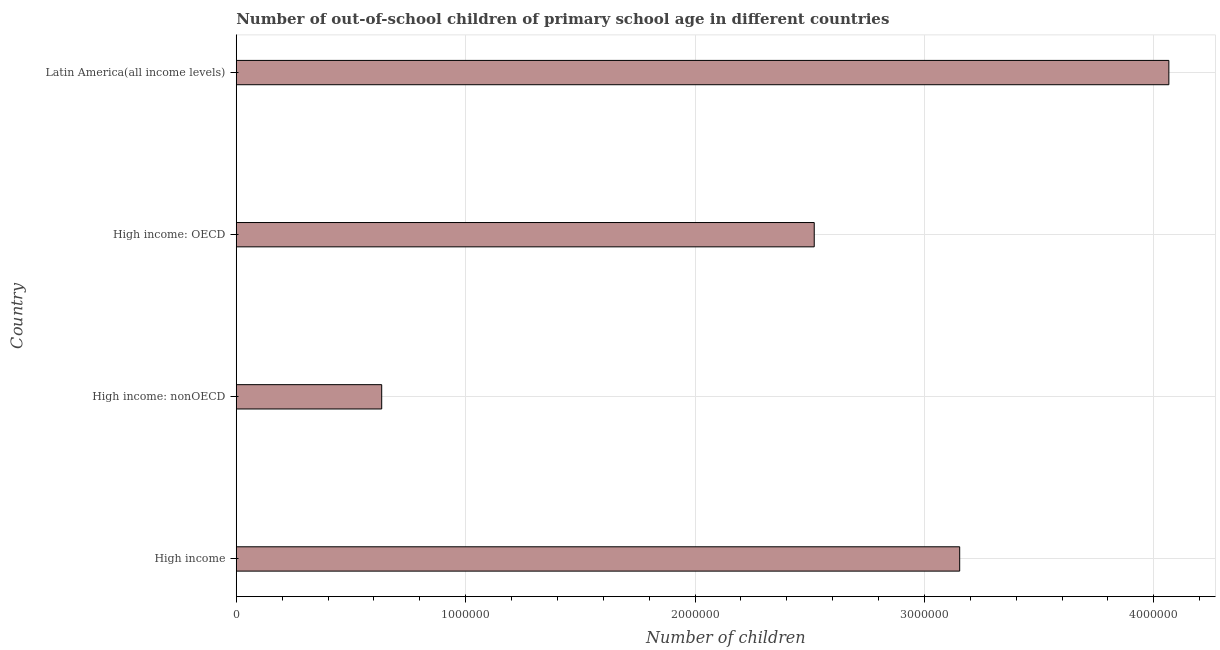Does the graph contain any zero values?
Ensure brevity in your answer.  No. Does the graph contain grids?
Your response must be concise. Yes. What is the title of the graph?
Provide a short and direct response. Number of out-of-school children of primary school age in different countries. What is the label or title of the X-axis?
Provide a short and direct response. Number of children. What is the number of out-of-school children in High income?
Make the answer very short. 3.15e+06. Across all countries, what is the maximum number of out-of-school children?
Offer a very short reply. 4.07e+06. Across all countries, what is the minimum number of out-of-school children?
Your answer should be compact. 6.34e+05. In which country was the number of out-of-school children maximum?
Offer a terse response. Latin America(all income levels). In which country was the number of out-of-school children minimum?
Make the answer very short. High income: nonOECD. What is the sum of the number of out-of-school children?
Your response must be concise. 1.04e+07. What is the difference between the number of out-of-school children in High income and High income: OECD?
Your answer should be very brief. 6.34e+05. What is the average number of out-of-school children per country?
Keep it short and to the point. 2.59e+06. What is the median number of out-of-school children?
Offer a very short reply. 2.84e+06. In how many countries, is the number of out-of-school children greater than 2000000 ?
Provide a succinct answer. 3. What is the ratio of the number of out-of-school children in High income to that in Latin America(all income levels)?
Ensure brevity in your answer.  0.78. What is the difference between the highest and the second highest number of out-of-school children?
Ensure brevity in your answer.  9.12e+05. What is the difference between the highest and the lowest number of out-of-school children?
Your response must be concise. 3.43e+06. In how many countries, is the number of out-of-school children greater than the average number of out-of-school children taken over all countries?
Your response must be concise. 2. How many bars are there?
Keep it short and to the point. 4. Are the values on the major ticks of X-axis written in scientific E-notation?
Keep it short and to the point. No. What is the Number of children of High income?
Provide a succinct answer. 3.15e+06. What is the Number of children of High income: nonOECD?
Offer a very short reply. 6.34e+05. What is the Number of children of High income: OECD?
Make the answer very short. 2.52e+06. What is the Number of children of Latin America(all income levels)?
Offer a very short reply. 4.07e+06. What is the difference between the Number of children in High income and High income: nonOECD?
Give a very brief answer. 2.52e+06. What is the difference between the Number of children in High income and High income: OECD?
Keep it short and to the point. 6.34e+05. What is the difference between the Number of children in High income and Latin America(all income levels)?
Provide a succinct answer. -9.12e+05. What is the difference between the Number of children in High income: nonOECD and High income: OECD?
Provide a succinct answer. -1.89e+06. What is the difference between the Number of children in High income: nonOECD and Latin America(all income levels)?
Your answer should be very brief. -3.43e+06. What is the difference between the Number of children in High income: OECD and Latin America(all income levels)?
Provide a short and direct response. -1.55e+06. What is the ratio of the Number of children in High income to that in High income: nonOECD?
Ensure brevity in your answer.  4.97. What is the ratio of the Number of children in High income to that in High income: OECD?
Your answer should be compact. 1.25. What is the ratio of the Number of children in High income to that in Latin America(all income levels)?
Keep it short and to the point. 0.78. What is the ratio of the Number of children in High income: nonOECD to that in High income: OECD?
Ensure brevity in your answer.  0.25. What is the ratio of the Number of children in High income: nonOECD to that in Latin America(all income levels)?
Provide a short and direct response. 0.16. What is the ratio of the Number of children in High income: OECD to that in Latin America(all income levels)?
Give a very brief answer. 0.62. 